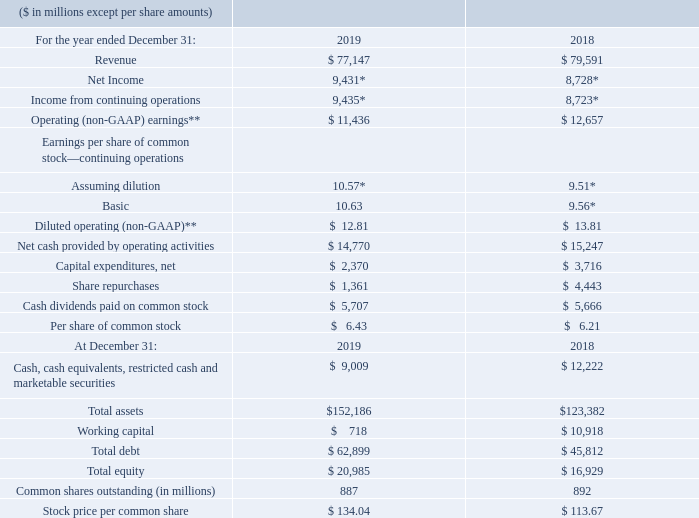Financial Highlights
International Business Machines Corporation and Subsidiary Companies
* Includes charges of $0.1 billion in 2019 and $2.0 billion in 2018 associated with U.S. tax reform.
** See page 46 for a reconciliation of net income to operating earnings.
What does Net Income include? Includes charges of $0.1 billion in 2019 and $2.0 billion in 2018 associated with u.s. tax reform. What was the Operating (non-GAAP) earnings in 2019?
Answer scale should be: million. 11,436. What is the Basic earnings per share in 2019? 10.63. What is the increase / (decrease) in revenue from 2018 to 2019?
Answer scale should be: million. 77,147 - 79,591
Answer: -2444. What are the total assets increase / (decrease) from 2018 to 2019?
Answer scale should be: million. 152,186 - 123,382
Answer: 28804. What is the Debt to Capital Ratio in 2019?
Answer scale should be: percent. 62,899 / (62,899 + 45,812)
Answer: 57.86. 